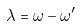<formula> <loc_0><loc_0><loc_500><loc_500>\lambda = \omega - \omega ^ { \prime }</formula> 